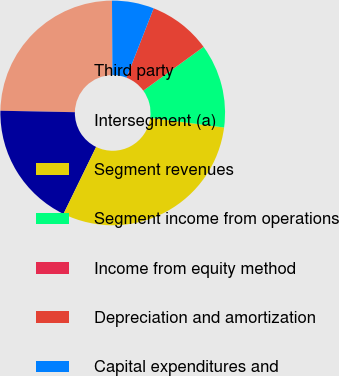Convert chart. <chart><loc_0><loc_0><loc_500><loc_500><pie_chart><fcel>Third party<fcel>Intersegment (a)<fcel>Segment revenues<fcel>Segment income from operations<fcel>Income from equity method<fcel>Depreciation and amortization<fcel>Capital expenditures and<nl><fcel>24.59%<fcel>18.09%<fcel>30.15%<fcel>12.07%<fcel>0.01%<fcel>9.05%<fcel>6.04%<nl></chart> 